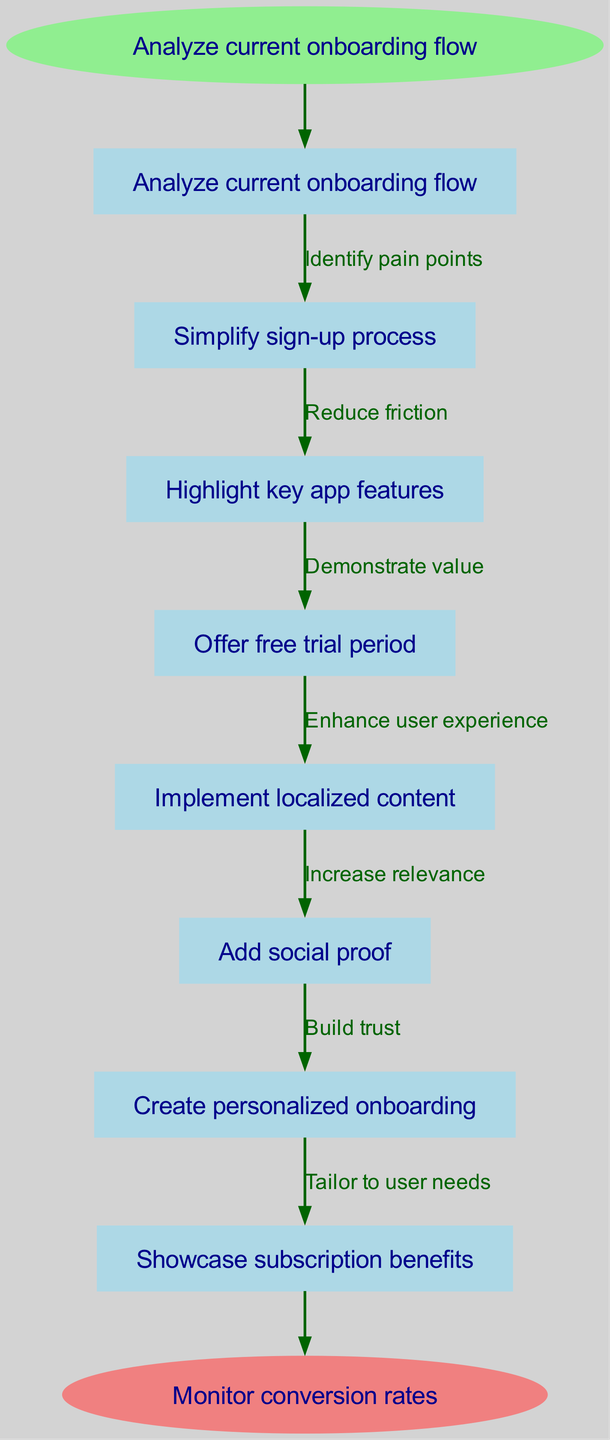What is the starting node of the onboarding optimization process? The starting node is explicitly labeled as "Analyze current onboarding flow." This can be found at the beginning of the flow chart, from where the process initiates.
Answer: Analyze current onboarding flow How many nodes are present in the diagram? The diagram contains six main nodes listed under "nodes," plus one start node and one end node. By counting these, we find a total of eight nodes in the entire flow chart.
Answer: eight What is the last action before reaching the end node? The last action before reaching the end node is "Showcase subscription benefits." This action is the final step in the flow after "Create personalized onboarding" before monitoring conversion rates.
Answer: Showcase subscription benefits Which node follows "Highlight key app features"? The node that follows "Highlight key app features" is "Offer free trial period." This is indicated by the directed edge in the flow chart showing the progression of steps.
Answer: Offer free trial period What is the relationship between "Add social proof" and "Create personalized onboarding"? The relationship between "Add social proof" and "Create personalized onboarding" is denoted by the edge labeled "Build trust." This indicates that adding social proof is a step leading to personalized onboarding due to the trust it builds.
Answer: Build trust What step emphasizes enhancing user experience? The step that emphasizes enhancing user experience is "Implement localized content." This follows "Offer free trial period" in the flow, indicating that localized content improves the overall experience of the user during onboarding.
Answer: Implement localized content How many edges are there in total in this diagram? To find the number of edges, we count each directed connection between nodes. There are six edges listed, plus one edge connecting the last node to the end node, resulting in a total of seven edges.
Answer: seven What is the label of the edge between "Simplify sign-up process" and "Highlight key app features"? The label of the edge between "Simplify sign-up process" and "Highlight key app features" is "Reduce friction." This label describes the effect of simplifying the sign-up on highlighting the app's features.
Answer: Reduce friction 